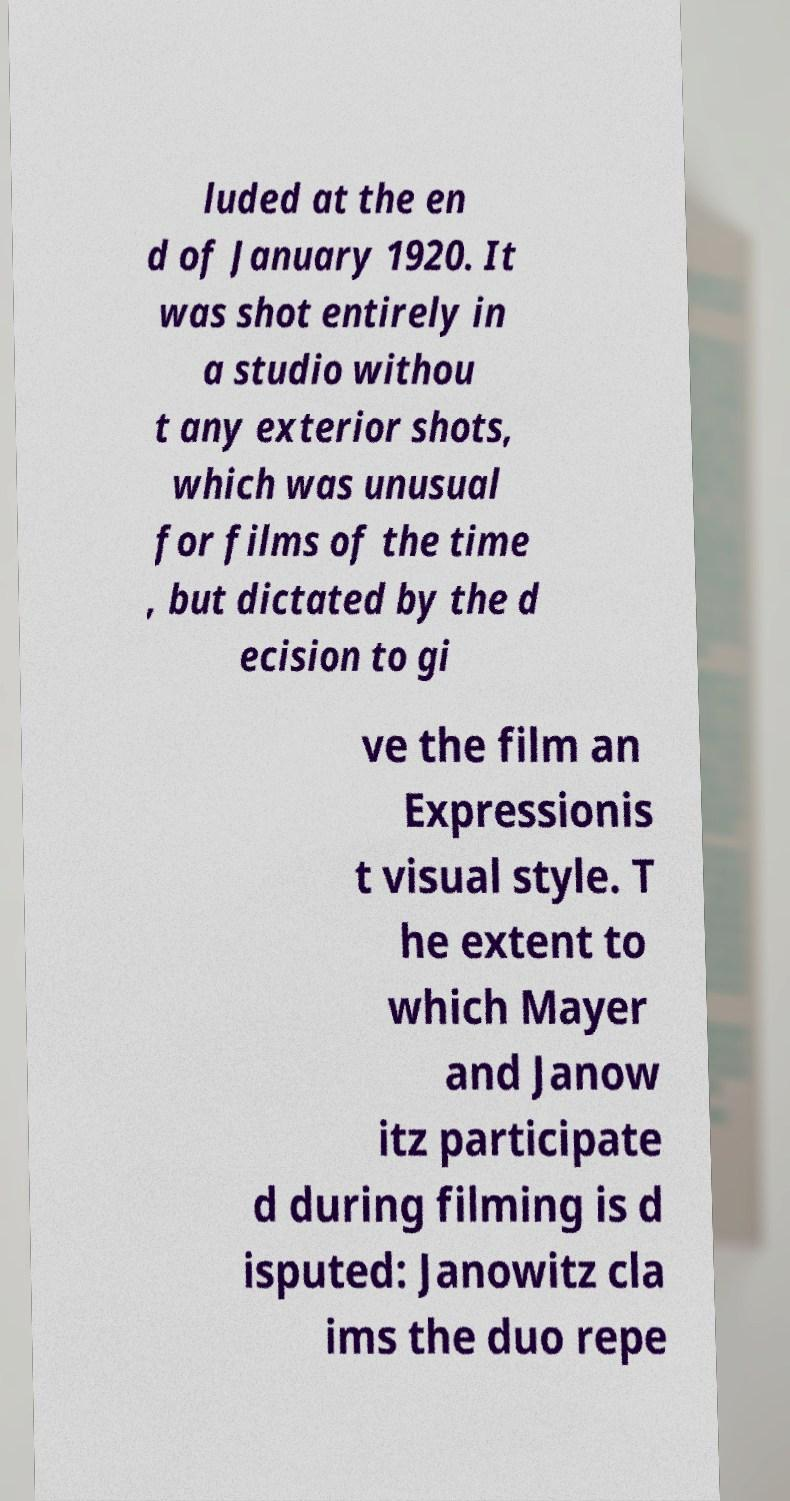Please read and relay the text visible in this image. What does it say? luded at the en d of January 1920. It was shot entirely in a studio withou t any exterior shots, which was unusual for films of the time , but dictated by the d ecision to gi ve the film an Expressionis t visual style. T he extent to which Mayer and Janow itz participate d during filming is d isputed: Janowitz cla ims the duo repe 